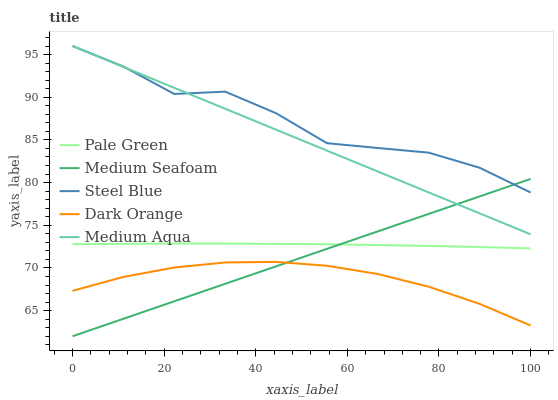Does Dark Orange have the minimum area under the curve?
Answer yes or no. Yes. Does Steel Blue have the maximum area under the curve?
Answer yes or no. Yes. Does Pale Green have the minimum area under the curve?
Answer yes or no. No. Does Pale Green have the maximum area under the curve?
Answer yes or no. No. Is Medium Aqua the smoothest?
Answer yes or no. Yes. Is Steel Blue the roughest?
Answer yes or no. Yes. Is Pale Green the smoothest?
Answer yes or no. No. Is Pale Green the roughest?
Answer yes or no. No. Does Medium Seafoam have the lowest value?
Answer yes or no. Yes. Does Pale Green have the lowest value?
Answer yes or no. No. Does Steel Blue have the highest value?
Answer yes or no. Yes. Does Pale Green have the highest value?
Answer yes or no. No. Is Pale Green less than Steel Blue?
Answer yes or no. Yes. Is Pale Green greater than Dark Orange?
Answer yes or no. Yes. Does Medium Aqua intersect Steel Blue?
Answer yes or no. Yes. Is Medium Aqua less than Steel Blue?
Answer yes or no. No. Is Medium Aqua greater than Steel Blue?
Answer yes or no. No. Does Pale Green intersect Steel Blue?
Answer yes or no. No. 